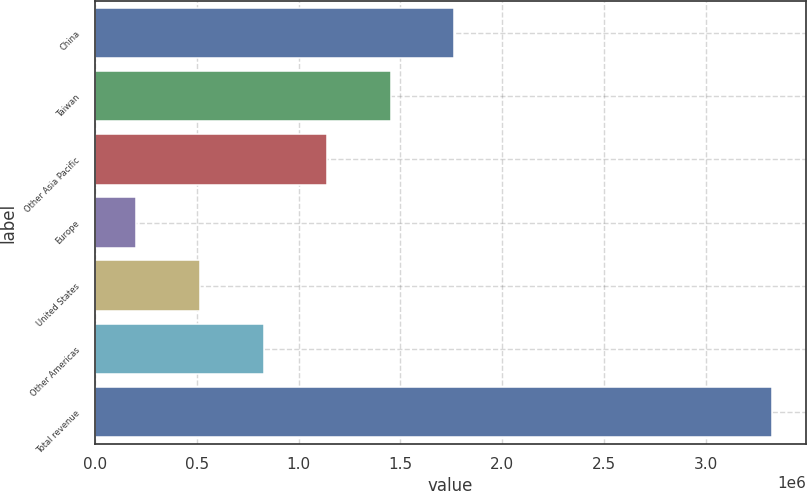Convert chart. <chart><loc_0><loc_0><loc_500><loc_500><bar_chart><fcel>China<fcel>Taiwan<fcel>Other Asia Pacific<fcel>Europe<fcel>United States<fcel>Other Americas<fcel>Total revenue<nl><fcel>1.7651e+06<fcel>1.45283e+06<fcel>1.14057e+06<fcel>203760<fcel>516028<fcel>828297<fcel>3.32644e+06<nl></chart> 